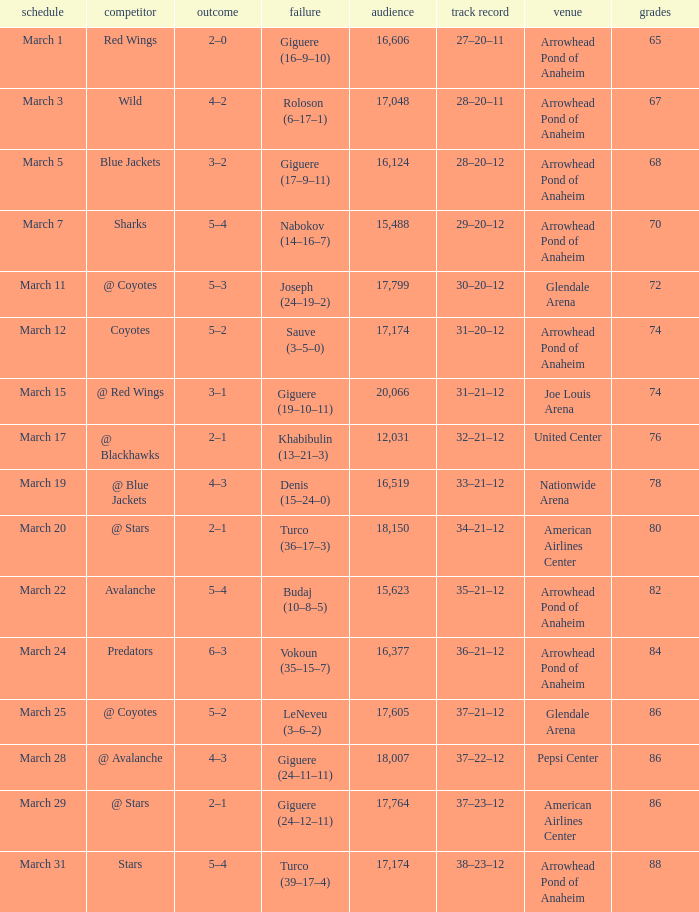What is the Attendance of the game with a Score of 3–2? 1.0. 